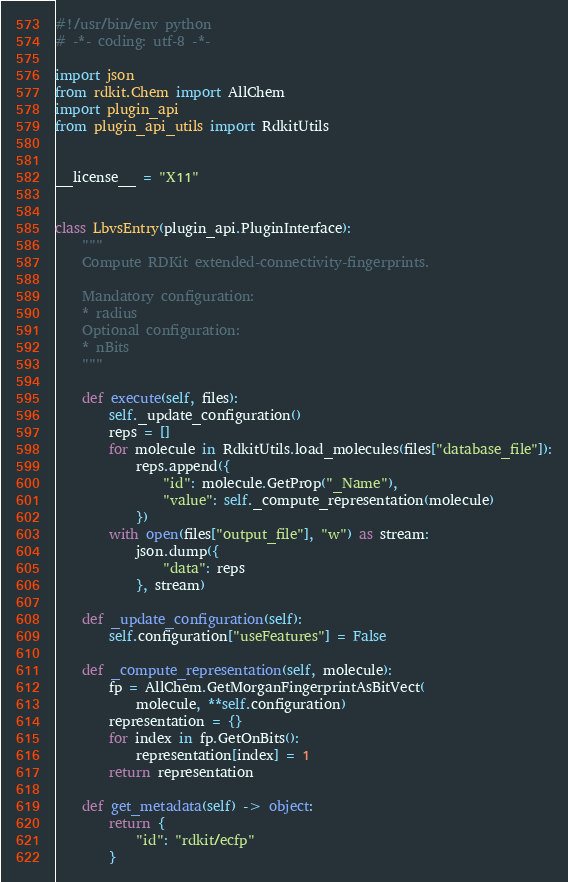<code> <loc_0><loc_0><loc_500><loc_500><_Python_>#!/usr/bin/env python
# -*- coding: utf-8 -*-

import json
from rdkit.Chem import AllChem
import plugin_api
from plugin_api_utils import RdkitUtils


__license__ = "X11"


class LbvsEntry(plugin_api.PluginInterface):
    """
    Compute RDKit extended-connectivity-fingerprints.

    Mandatory configuration:
    * radius
    Optional configuration:
    * nBits
    """

    def execute(self, files):
        self._update_configuration()
        reps = []
        for molecule in RdkitUtils.load_molecules(files["database_file"]):
            reps.append({
                "id": molecule.GetProp("_Name"),
                "value": self._compute_representation(molecule)
            })
        with open(files["output_file"], "w") as stream:
            json.dump({
                "data": reps
            }, stream)

    def _update_configuration(self):
        self.configuration["useFeatures"] = False

    def _compute_representation(self, molecule):
        fp = AllChem.GetMorganFingerprintAsBitVect(
            molecule, **self.configuration)
        representation = {}
        for index in fp.GetOnBits():
            representation[index] = 1
        return representation

    def get_metadata(self) -> object:
        return {
            "id": "rdkit/ecfp"
        }
</code> 